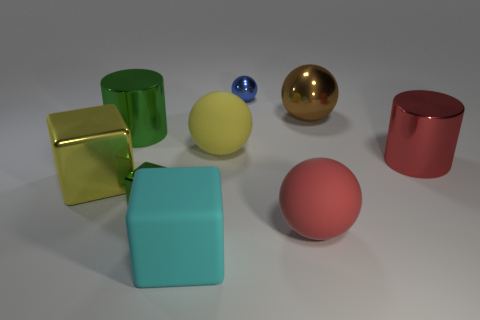Add 1 gray metallic cylinders. How many objects exist? 10 Subtract all yellow rubber balls. How many balls are left? 3 Subtract all green cylinders. How many cylinders are left? 1 Subtract all spheres. How many objects are left? 5 Subtract 3 cubes. How many cubes are left? 0 Subtract all big matte objects. Subtract all yellow spheres. How many objects are left? 5 Add 4 big matte spheres. How many big matte spheres are left? 6 Add 5 yellow shiny things. How many yellow shiny things exist? 6 Subtract 0 gray spheres. How many objects are left? 9 Subtract all cyan blocks. Subtract all brown cylinders. How many blocks are left? 2 